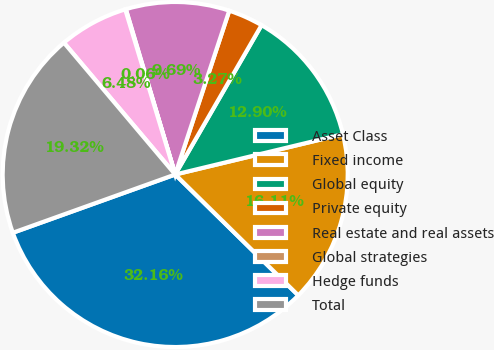<chart> <loc_0><loc_0><loc_500><loc_500><pie_chart><fcel>Asset Class<fcel>Fixed income<fcel>Global equity<fcel>Private equity<fcel>Real estate and real assets<fcel>Global strategies<fcel>Hedge funds<fcel>Total<nl><fcel>32.16%<fcel>16.11%<fcel>12.9%<fcel>3.27%<fcel>9.69%<fcel>0.06%<fcel>6.48%<fcel>19.32%<nl></chart> 